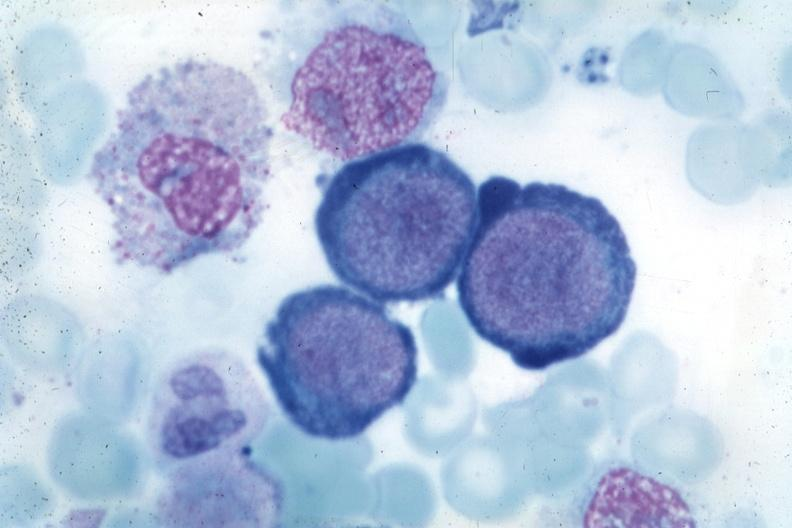s tuberculous peritonitis present?
Answer the question using a single word or phrase. No 